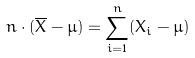<formula> <loc_0><loc_0><loc_500><loc_500>n \cdot ( { \overline { X } } - \mu ) = \sum _ { i = 1 } ^ { n } ( X _ { i } - \mu )</formula> 